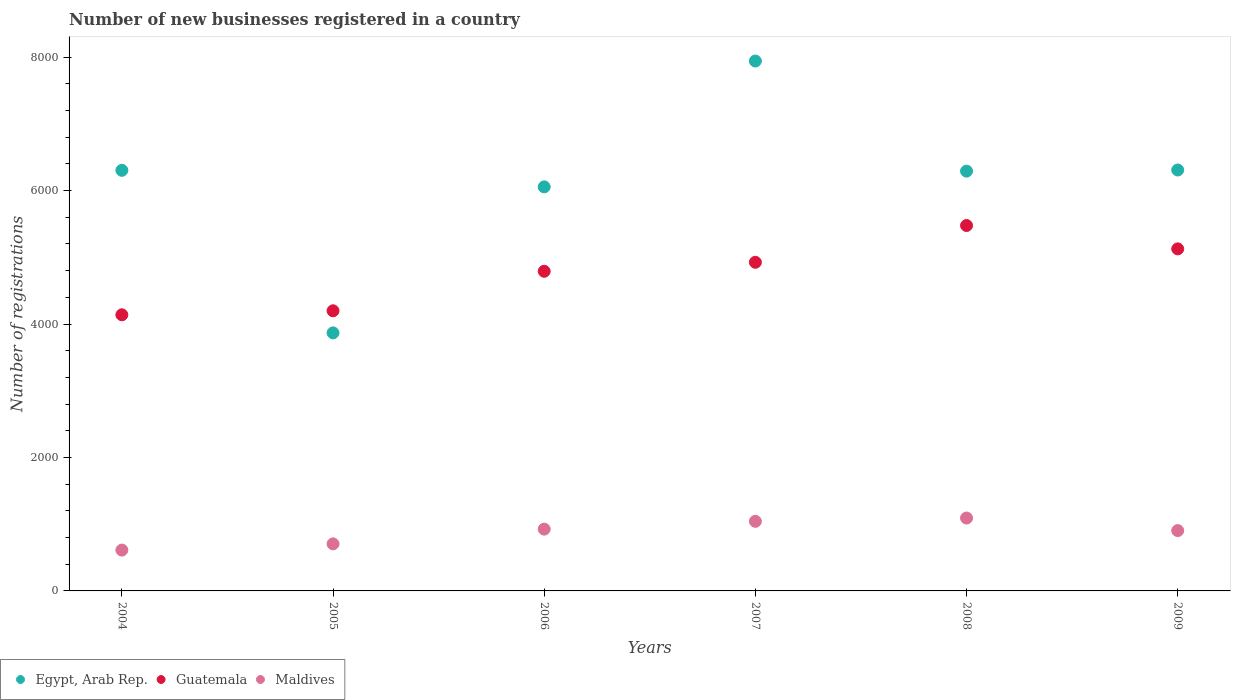How many different coloured dotlines are there?
Ensure brevity in your answer.  3. What is the number of new businesses registered in Maldives in 2006?
Ensure brevity in your answer.  926. Across all years, what is the maximum number of new businesses registered in Egypt, Arab Rep.?
Give a very brief answer. 7941. Across all years, what is the minimum number of new businesses registered in Guatemala?
Offer a terse response. 4138. In which year was the number of new businesses registered in Maldives minimum?
Your answer should be compact. 2004. What is the total number of new businesses registered in Egypt, Arab Rep. in the graph?
Make the answer very short. 3.68e+04. What is the difference between the number of new businesses registered in Maldives in 2005 and that in 2006?
Your response must be concise. -221. What is the difference between the number of new businesses registered in Egypt, Arab Rep. in 2009 and the number of new businesses registered in Guatemala in 2008?
Make the answer very short. 832. What is the average number of new businesses registered in Egypt, Arab Rep. per year?
Make the answer very short. 6127.5. In the year 2005, what is the difference between the number of new businesses registered in Maldives and number of new businesses registered in Egypt, Arab Rep.?
Your response must be concise. -3162. In how many years, is the number of new businesses registered in Egypt, Arab Rep. greater than 4000?
Your answer should be compact. 5. What is the ratio of the number of new businesses registered in Guatemala in 2008 to that in 2009?
Offer a terse response. 1.07. Is the number of new businesses registered in Egypt, Arab Rep. in 2005 less than that in 2007?
Offer a terse response. Yes. What is the difference between the highest and the second highest number of new businesses registered in Egypt, Arab Rep.?
Your response must be concise. 1633. What is the difference between the highest and the lowest number of new businesses registered in Egypt, Arab Rep.?
Provide a short and direct response. 4074. Is the sum of the number of new businesses registered in Maldives in 2004 and 2006 greater than the maximum number of new businesses registered in Guatemala across all years?
Provide a succinct answer. No. Does the number of new businesses registered in Egypt, Arab Rep. monotonically increase over the years?
Give a very brief answer. No. Is the number of new businesses registered in Guatemala strictly greater than the number of new businesses registered in Egypt, Arab Rep. over the years?
Offer a terse response. No. Is the number of new businesses registered in Guatemala strictly less than the number of new businesses registered in Egypt, Arab Rep. over the years?
Keep it short and to the point. No. How many dotlines are there?
Offer a very short reply. 3. Are the values on the major ticks of Y-axis written in scientific E-notation?
Make the answer very short. No. Does the graph contain any zero values?
Keep it short and to the point. No. Does the graph contain grids?
Your answer should be compact. No. How many legend labels are there?
Ensure brevity in your answer.  3. How are the legend labels stacked?
Provide a succinct answer. Horizontal. What is the title of the graph?
Give a very brief answer. Number of new businesses registered in a country. What is the label or title of the Y-axis?
Make the answer very short. Number of registrations. What is the Number of registrations of Egypt, Arab Rep. in 2004?
Offer a very short reply. 6303. What is the Number of registrations of Guatemala in 2004?
Your answer should be very brief. 4138. What is the Number of registrations in Maldives in 2004?
Your answer should be compact. 612. What is the Number of registrations in Egypt, Arab Rep. in 2005?
Give a very brief answer. 3867. What is the Number of registrations of Guatemala in 2005?
Offer a terse response. 4198. What is the Number of registrations of Maldives in 2005?
Keep it short and to the point. 705. What is the Number of registrations of Egypt, Arab Rep. in 2006?
Provide a succinct answer. 6055. What is the Number of registrations in Guatemala in 2006?
Provide a succinct answer. 4790. What is the Number of registrations of Maldives in 2006?
Your response must be concise. 926. What is the Number of registrations of Egypt, Arab Rep. in 2007?
Offer a very short reply. 7941. What is the Number of registrations in Guatemala in 2007?
Your answer should be very brief. 4925. What is the Number of registrations of Maldives in 2007?
Ensure brevity in your answer.  1043. What is the Number of registrations of Egypt, Arab Rep. in 2008?
Make the answer very short. 6291. What is the Number of registrations of Guatemala in 2008?
Ensure brevity in your answer.  5476. What is the Number of registrations of Maldives in 2008?
Provide a short and direct response. 1092. What is the Number of registrations in Egypt, Arab Rep. in 2009?
Provide a short and direct response. 6308. What is the Number of registrations of Guatemala in 2009?
Make the answer very short. 5126. What is the Number of registrations in Maldives in 2009?
Make the answer very short. 904. Across all years, what is the maximum Number of registrations in Egypt, Arab Rep.?
Your answer should be compact. 7941. Across all years, what is the maximum Number of registrations in Guatemala?
Make the answer very short. 5476. Across all years, what is the maximum Number of registrations of Maldives?
Provide a short and direct response. 1092. Across all years, what is the minimum Number of registrations of Egypt, Arab Rep.?
Your answer should be very brief. 3867. Across all years, what is the minimum Number of registrations of Guatemala?
Give a very brief answer. 4138. Across all years, what is the minimum Number of registrations of Maldives?
Offer a terse response. 612. What is the total Number of registrations in Egypt, Arab Rep. in the graph?
Your answer should be compact. 3.68e+04. What is the total Number of registrations in Guatemala in the graph?
Offer a terse response. 2.87e+04. What is the total Number of registrations in Maldives in the graph?
Your response must be concise. 5282. What is the difference between the Number of registrations of Egypt, Arab Rep. in 2004 and that in 2005?
Your answer should be very brief. 2436. What is the difference between the Number of registrations of Guatemala in 2004 and that in 2005?
Provide a succinct answer. -60. What is the difference between the Number of registrations in Maldives in 2004 and that in 2005?
Offer a terse response. -93. What is the difference between the Number of registrations of Egypt, Arab Rep. in 2004 and that in 2006?
Make the answer very short. 248. What is the difference between the Number of registrations of Guatemala in 2004 and that in 2006?
Your answer should be compact. -652. What is the difference between the Number of registrations of Maldives in 2004 and that in 2006?
Offer a terse response. -314. What is the difference between the Number of registrations of Egypt, Arab Rep. in 2004 and that in 2007?
Your answer should be very brief. -1638. What is the difference between the Number of registrations of Guatemala in 2004 and that in 2007?
Ensure brevity in your answer.  -787. What is the difference between the Number of registrations of Maldives in 2004 and that in 2007?
Offer a very short reply. -431. What is the difference between the Number of registrations of Egypt, Arab Rep. in 2004 and that in 2008?
Ensure brevity in your answer.  12. What is the difference between the Number of registrations of Guatemala in 2004 and that in 2008?
Make the answer very short. -1338. What is the difference between the Number of registrations of Maldives in 2004 and that in 2008?
Offer a terse response. -480. What is the difference between the Number of registrations in Egypt, Arab Rep. in 2004 and that in 2009?
Give a very brief answer. -5. What is the difference between the Number of registrations of Guatemala in 2004 and that in 2009?
Your answer should be very brief. -988. What is the difference between the Number of registrations in Maldives in 2004 and that in 2009?
Your response must be concise. -292. What is the difference between the Number of registrations in Egypt, Arab Rep. in 2005 and that in 2006?
Give a very brief answer. -2188. What is the difference between the Number of registrations of Guatemala in 2005 and that in 2006?
Ensure brevity in your answer.  -592. What is the difference between the Number of registrations in Maldives in 2005 and that in 2006?
Ensure brevity in your answer.  -221. What is the difference between the Number of registrations in Egypt, Arab Rep. in 2005 and that in 2007?
Your response must be concise. -4074. What is the difference between the Number of registrations in Guatemala in 2005 and that in 2007?
Provide a succinct answer. -727. What is the difference between the Number of registrations of Maldives in 2005 and that in 2007?
Give a very brief answer. -338. What is the difference between the Number of registrations in Egypt, Arab Rep. in 2005 and that in 2008?
Provide a succinct answer. -2424. What is the difference between the Number of registrations of Guatemala in 2005 and that in 2008?
Ensure brevity in your answer.  -1278. What is the difference between the Number of registrations of Maldives in 2005 and that in 2008?
Ensure brevity in your answer.  -387. What is the difference between the Number of registrations in Egypt, Arab Rep. in 2005 and that in 2009?
Make the answer very short. -2441. What is the difference between the Number of registrations in Guatemala in 2005 and that in 2009?
Offer a very short reply. -928. What is the difference between the Number of registrations in Maldives in 2005 and that in 2009?
Your answer should be very brief. -199. What is the difference between the Number of registrations in Egypt, Arab Rep. in 2006 and that in 2007?
Your response must be concise. -1886. What is the difference between the Number of registrations in Guatemala in 2006 and that in 2007?
Offer a very short reply. -135. What is the difference between the Number of registrations in Maldives in 2006 and that in 2007?
Give a very brief answer. -117. What is the difference between the Number of registrations of Egypt, Arab Rep. in 2006 and that in 2008?
Offer a terse response. -236. What is the difference between the Number of registrations of Guatemala in 2006 and that in 2008?
Your answer should be very brief. -686. What is the difference between the Number of registrations of Maldives in 2006 and that in 2008?
Make the answer very short. -166. What is the difference between the Number of registrations in Egypt, Arab Rep. in 2006 and that in 2009?
Provide a short and direct response. -253. What is the difference between the Number of registrations of Guatemala in 2006 and that in 2009?
Provide a succinct answer. -336. What is the difference between the Number of registrations of Egypt, Arab Rep. in 2007 and that in 2008?
Make the answer very short. 1650. What is the difference between the Number of registrations of Guatemala in 2007 and that in 2008?
Give a very brief answer. -551. What is the difference between the Number of registrations of Maldives in 2007 and that in 2008?
Offer a terse response. -49. What is the difference between the Number of registrations in Egypt, Arab Rep. in 2007 and that in 2009?
Your answer should be compact. 1633. What is the difference between the Number of registrations in Guatemala in 2007 and that in 2009?
Make the answer very short. -201. What is the difference between the Number of registrations of Maldives in 2007 and that in 2009?
Offer a very short reply. 139. What is the difference between the Number of registrations of Guatemala in 2008 and that in 2009?
Make the answer very short. 350. What is the difference between the Number of registrations in Maldives in 2008 and that in 2009?
Offer a terse response. 188. What is the difference between the Number of registrations in Egypt, Arab Rep. in 2004 and the Number of registrations in Guatemala in 2005?
Keep it short and to the point. 2105. What is the difference between the Number of registrations of Egypt, Arab Rep. in 2004 and the Number of registrations of Maldives in 2005?
Offer a very short reply. 5598. What is the difference between the Number of registrations of Guatemala in 2004 and the Number of registrations of Maldives in 2005?
Offer a very short reply. 3433. What is the difference between the Number of registrations of Egypt, Arab Rep. in 2004 and the Number of registrations of Guatemala in 2006?
Make the answer very short. 1513. What is the difference between the Number of registrations of Egypt, Arab Rep. in 2004 and the Number of registrations of Maldives in 2006?
Give a very brief answer. 5377. What is the difference between the Number of registrations in Guatemala in 2004 and the Number of registrations in Maldives in 2006?
Offer a very short reply. 3212. What is the difference between the Number of registrations of Egypt, Arab Rep. in 2004 and the Number of registrations of Guatemala in 2007?
Provide a short and direct response. 1378. What is the difference between the Number of registrations of Egypt, Arab Rep. in 2004 and the Number of registrations of Maldives in 2007?
Your answer should be very brief. 5260. What is the difference between the Number of registrations in Guatemala in 2004 and the Number of registrations in Maldives in 2007?
Provide a short and direct response. 3095. What is the difference between the Number of registrations of Egypt, Arab Rep. in 2004 and the Number of registrations of Guatemala in 2008?
Give a very brief answer. 827. What is the difference between the Number of registrations of Egypt, Arab Rep. in 2004 and the Number of registrations of Maldives in 2008?
Offer a very short reply. 5211. What is the difference between the Number of registrations of Guatemala in 2004 and the Number of registrations of Maldives in 2008?
Provide a short and direct response. 3046. What is the difference between the Number of registrations in Egypt, Arab Rep. in 2004 and the Number of registrations in Guatemala in 2009?
Your answer should be compact. 1177. What is the difference between the Number of registrations of Egypt, Arab Rep. in 2004 and the Number of registrations of Maldives in 2009?
Provide a succinct answer. 5399. What is the difference between the Number of registrations of Guatemala in 2004 and the Number of registrations of Maldives in 2009?
Keep it short and to the point. 3234. What is the difference between the Number of registrations of Egypt, Arab Rep. in 2005 and the Number of registrations of Guatemala in 2006?
Your answer should be very brief. -923. What is the difference between the Number of registrations of Egypt, Arab Rep. in 2005 and the Number of registrations of Maldives in 2006?
Offer a very short reply. 2941. What is the difference between the Number of registrations in Guatemala in 2005 and the Number of registrations in Maldives in 2006?
Make the answer very short. 3272. What is the difference between the Number of registrations in Egypt, Arab Rep. in 2005 and the Number of registrations in Guatemala in 2007?
Your answer should be very brief. -1058. What is the difference between the Number of registrations of Egypt, Arab Rep. in 2005 and the Number of registrations of Maldives in 2007?
Ensure brevity in your answer.  2824. What is the difference between the Number of registrations of Guatemala in 2005 and the Number of registrations of Maldives in 2007?
Your answer should be very brief. 3155. What is the difference between the Number of registrations of Egypt, Arab Rep. in 2005 and the Number of registrations of Guatemala in 2008?
Provide a short and direct response. -1609. What is the difference between the Number of registrations in Egypt, Arab Rep. in 2005 and the Number of registrations in Maldives in 2008?
Keep it short and to the point. 2775. What is the difference between the Number of registrations in Guatemala in 2005 and the Number of registrations in Maldives in 2008?
Your response must be concise. 3106. What is the difference between the Number of registrations of Egypt, Arab Rep. in 2005 and the Number of registrations of Guatemala in 2009?
Provide a succinct answer. -1259. What is the difference between the Number of registrations of Egypt, Arab Rep. in 2005 and the Number of registrations of Maldives in 2009?
Your answer should be compact. 2963. What is the difference between the Number of registrations in Guatemala in 2005 and the Number of registrations in Maldives in 2009?
Ensure brevity in your answer.  3294. What is the difference between the Number of registrations of Egypt, Arab Rep. in 2006 and the Number of registrations of Guatemala in 2007?
Provide a short and direct response. 1130. What is the difference between the Number of registrations in Egypt, Arab Rep. in 2006 and the Number of registrations in Maldives in 2007?
Provide a succinct answer. 5012. What is the difference between the Number of registrations in Guatemala in 2006 and the Number of registrations in Maldives in 2007?
Your response must be concise. 3747. What is the difference between the Number of registrations of Egypt, Arab Rep. in 2006 and the Number of registrations of Guatemala in 2008?
Your answer should be compact. 579. What is the difference between the Number of registrations in Egypt, Arab Rep. in 2006 and the Number of registrations in Maldives in 2008?
Your answer should be very brief. 4963. What is the difference between the Number of registrations in Guatemala in 2006 and the Number of registrations in Maldives in 2008?
Your response must be concise. 3698. What is the difference between the Number of registrations in Egypt, Arab Rep. in 2006 and the Number of registrations in Guatemala in 2009?
Offer a terse response. 929. What is the difference between the Number of registrations of Egypt, Arab Rep. in 2006 and the Number of registrations of Maldives in 2009?
Your response must be concise. 5151. What is the difference between the Number of registrations in Guatemala in 2006 and the Number of registrations in Maldives in 2009?
Provide a succinct answer. 3886. What is the difference between the Number of registrations in Egypt, Arab Rep. in 2007 and the Number of registrations in Guatemala in 2008?
Your answer should be very brief. 2465. What is the difference between the Number of registrations of Egypt, Arab Rep. in 2007 and the Number of registrations of Maldives in 2008?
Keep it short and to the point. 6849. What is the difference between the Number of registrations in Guatemala in 2007 and the Number of registrations in Maldives in 2008?
Your answer should be compact. 3833. What is the difference between the Number of registrations of Egypt, Arab Rep. in 2007 and the Number of registrations of Guatemala in 2009?
Ensure brevity in your answer.  2815. What is the difference between the Number of registrations in Egypt, Arab Rep. in 2007 and the Number of registrations in Maldives in 2009?
Your answer should be very brief. 7037. What is the difference between the Number of registrations of Guatemala in 2007 and the Number of registrations of Maldives in 2009?
Provide a short and direct response. 4021. What is the difference between the Number of registrations in Egypt, Arab Rep. in 2008 and the Number of registrations in Guatemala in 2009?
Your answer should be compact. 1165. What is the difference between the Number of registrations of Egypt, Arab Rep. in 2008 and the Number of registrations of Maldives in 2009?
Your answer should be very brief. 5387. What is the difference between the Number of registrations of Guatemala in 2008 and the Number of registrations of Maldives in 2009?
Provide a short and direct response. 4572. What is the average Number of registrations of Egypt, Arab Rep. per year?
Make the answer very short. 6127.5. What is the average Number of registrations in Guatemala per year?
Offer a very short reply. 4775.5. What is the average Number of registrations in Maldives per year?
Your response must be concise. 880.33. In the year 2004, what is the difference between the Number of registrations of Egypt, Arab Rep. and Number of registrations of Guatemala?
Your response must be concise. 2165. In the year 2004, what is the difference between the Number of registrations in Egypt, Arab Rep. and Number of registrations in Maldives?
Give a very brief answer. 5691. In the year 2004, what is the difference between the Number of registrations in Guatemala and Number of registrations in Maldives?
Provide a succinct answer. 3526. In the year 2005, what is the difference between the Number of registrations in Egypt, Arab Rep. and Number of registrations in Guatemala?
Offer a terse response. -331. In the year 2005, what is the difference between the Number of registrations in Egypt, Arab Rep. and Number of registrations in Maldives?
Provide a succinct answer. 3162. In the year 2005, what is the difference between the Number of registrations of Guatemala and Number of registrations of Maldives?
Make the answer very short. 3493. In the year 2006, what is the difference between the Number of registrations of Egypt, Arab Rep. and Number of registrations of Guatemala?
Your response must be concise. 1265. In the year 2006, what is the difference between the Number of registrations in Egypt, Arab Rep. and Number of registrations in Maldives?
Make the answer very short. 5129. In the year 2006, what is the difference between the Number of registrations in Guatemala and Number of registrations in Maldives?
Your answer should be very brief. 3864. In the year 2007, what is the difference between the Number of registrations of Egypt, Arab Rep. and Number of registrations of Guatemala?
Provide a succinct answer. 3016. In the year 2007, what is the difference between the Number of registrations in Egypt, Arab Rep. and Number of registrations in Maldives?
Give a very brief answer. 6898. In the year 2007, what is the difference between the Number of registrations of Guatemala and Number of registrations of Maldives?
Ensure brevity in your answer.  3882. In the year 2008, what is the difference between the Number of registrations in Egypt, Arab Rep. and Number of registrations in Guatemala?
Provide a short and direct response. 815. In the year 2008, what is the difference between the Number of registrations in Egypt, Arab Rep. and Number of registrations in Maldives?
Keep it short and to the point. 5199. In the year 2008, what is the difference between the Number of registrations of Guatemala and Number of registrations of Maldives?
Provide a short and direct response. 4384. In the year 2009, what is the difference between the Number of registrations of Egypt, Arab Rep. and Number of registrations of Guatemala?
Your response must be concise. 1182. In the year 2009, what is the difference between the Number of registrations of Egypt, Arab Rep. and Number of registrations of Maldives?
Ensure brevity in your answer.  5404. In the year 2009, what is the difference between the Number of registrations of Guatemala and Number of registrations of Maldives?
Keep it short and to the point. 4222. What is the ratio of the Number of registrations in Egypt, Arab Rep. in 2004 to that in 2005?
Your answer should be very brief. 1.63. What is the ratio of the Number of registrations in Guatemala in 2004 to that in 2005?
Offer a very short reply. 0.99. What is the ratio of the Number of registrations in Maldives in 2004 to that in 2005?
Your response must be concise. 0.87. What is the ratio of the Number of registrations in Egypt, Arab Rep. in 2004 to that in 2006?
Make the answer very short. 1.04. What is the ratio of the Number of registrations in Guatemala in 2004 to that in 2006?
Make the answer very short. 0.86. What is the ratio of the Number of registrations in Maldives in 2004 to that in 2006?
Your response must be concise. 0.66. What is the ratio of the Number of registrations in Egypt, Arab Rep. in 2004 to that in 2007?
Offer a very short reply. 0.79. What is the ratio of the Number of registrations in Guatemala in 2004 to that in 2007?
Ensure brevity in your answer.  0.84. What is the ratio of the Number of registrations of Maldives in 2004 to that in 2007?
Your answer should be very brief. 0.59. What is the ratio of the Number of registrations in Egypt, Arab Rep. in 2004 to that in 2008?
Give a very brief answer. 1. What is the ratio of the Number of registrations in Guatemala in 2004 to that in 2008?
Your response must be concise. 0.76. What is the ratio of the Number of registrations in Maldives in 2004 to that in 2008?
Provide a succinct answer. 0.56. What is the ratio of the Number of registrations of Egypt, Arab Rep. in 2004 to that in 2009?
Provide a short and direct response. 1. What is the ratio of the Number of registrations in Guatemala in 2004 to that in 2009?
Give a very brief answer. 0.81. What is the ratio of the Number of registrations in Maldives in 2004 to that in 2009?
Make the answer very short. 0.68. What is the ratio of the Number of registrations of Egypt, Arab Rep. in 2005 to that in 2006?
Make the answer very short. 0.64. What is the ratio of the Number of registrations of Guatemala in 2005 to that in 2006?
Offer a very short reply. 0.88. What is the ratio of the Number of registrations in Maldives in 2005 to that in 2006?
Provide a succinct answer. 0.76. What is the ratio of the Number of registrations in Egypt, Arab Rep. in 2005 to that in 2007?
Your answer should be very brief. 0.49. What is the ratio of the Number of registrations in Guatemala in 2005 to that in 2007?
Offer a terse response. 0.85. What is the ratio of the Number of registrations in Maldives in 2005 to that in 2007?
Your answer should be compact. 0.68. What is the ratio of the Number of registrations of Egypt, Arab Rep. in 2005 to that in 2008?
Offer a terse response. 0.61. What is the ratio of the Number of registrations of Guatemala in 2005 to that in 2008?
Your response must be concise. 0.77. What is the ratio of the Number of registrations in Maldives in 2005 to that in 2008?
Offer a very short reply. 0.65. What is the ratio of the Number of registrations of Egypt, Arab Rep. in 2005 to that in 2009?
Ensure brevity in your answer.  0.61. What is the ratio of the Number of registrations in Guatemala in 2005 to that in 2009?
Ensure brevity in your answer.  0.82. What is the ratio of the Number of registrations in Maldives in 2005 to that in 2009?
Your response must be concise. 0.78. What is the ratio of the Number of registrations of Egypt, Arab Rep. in 2006 to that in 2007?
Ensure brevity in your answer.  0.76. What is the ratio of the Number of registrations of Guatemala in 2006 to that in 2007?
Offer a terse response. 0.97. What is the ratio of the Number of registrations in Maldives in 2006 to that in 2007?
Keep it short and to the point. 0.89. What is the ratio of the Number of registrations in Egypt, Arab Rep. in 2006 to that in 2008?
Make the answer very short. 0.96. What is the ratio of the Number of registrations of Guatemala in 2006 to that in 2008?
Offer a very short reply. 0.87. What is the ratio of the Number of registrations of Maldives in 2006 to that in 2008?
Keep it short and to the point. 0.85. What is the ratio of the Number of registrations in Egypt, Arab Rep. in 2006 to that in 2009?
Keep it short and to the point. 0.96. What is the ratio of the Number of registrations in Guatemala in 2006 to that in 2009?
Your response must be concise. 0.93. What is the ratio of the Number of registrations of Maldives in 2006 to that in 2009?
Your answer should be very brief. 1.02. What is the ratio of the Number of registrations of Egypt, Arab Rep. in 2007 to that in 2008?
Keep it short and to the point. 1.26. What is the ratio of the Number of registrations of Guatemala in 2007 to that in 2008?
Offer a terse response. 0.9. What is the ratio of the Number of registrations in Maldives in 2007 to that in 2008?
Ensure brevity in your answer.  0.96. What is the ratio of the Number of registrations in Egypt, Arab Rep. in 2007 to that in 2009?
Give a very brief answer. 1.26. What is the ratio of the Number of registrations of Guatemala in 2007 to that in 2009?
Ensure brevity in your answer.  0.96. What is the ratio of the Number of registrations of Maldives in 2007 to that in 2009?
Keep it short and to the point. 1.15. What is the ratio of the Number of registrations in Guatemala in 2008 to that in 2009?
Give a very brief answer. 1.07. What is the ratio of the Number of registrations in Maldives in 2008 to that in 2009?
Keep it short and to the point. 1.21. What is the difference between the highest and the second highest Number of registrations in Egypt, Arab Rep.?
Ensure brevity in your answer.  1633. What is the difference between the highest and the second highest Number of registrations in Guatemala?
Offer a terse response. 350. What is the difference between the highest and the second highest Number of registrations of Maldives?
Offer a very short reply. 49. What is the difference between the highest and the lowest Number of registrations of Egypt, Arab Rep.?
Keep it short and to the point. 4074. What is the difference between the highest and the lowest Number of registrations of Guatemala?
Make the answer very short. 1338. What is the difference between the highest and the lowest Number of registrations of Maldives?
Give a very brief answer. 480. 